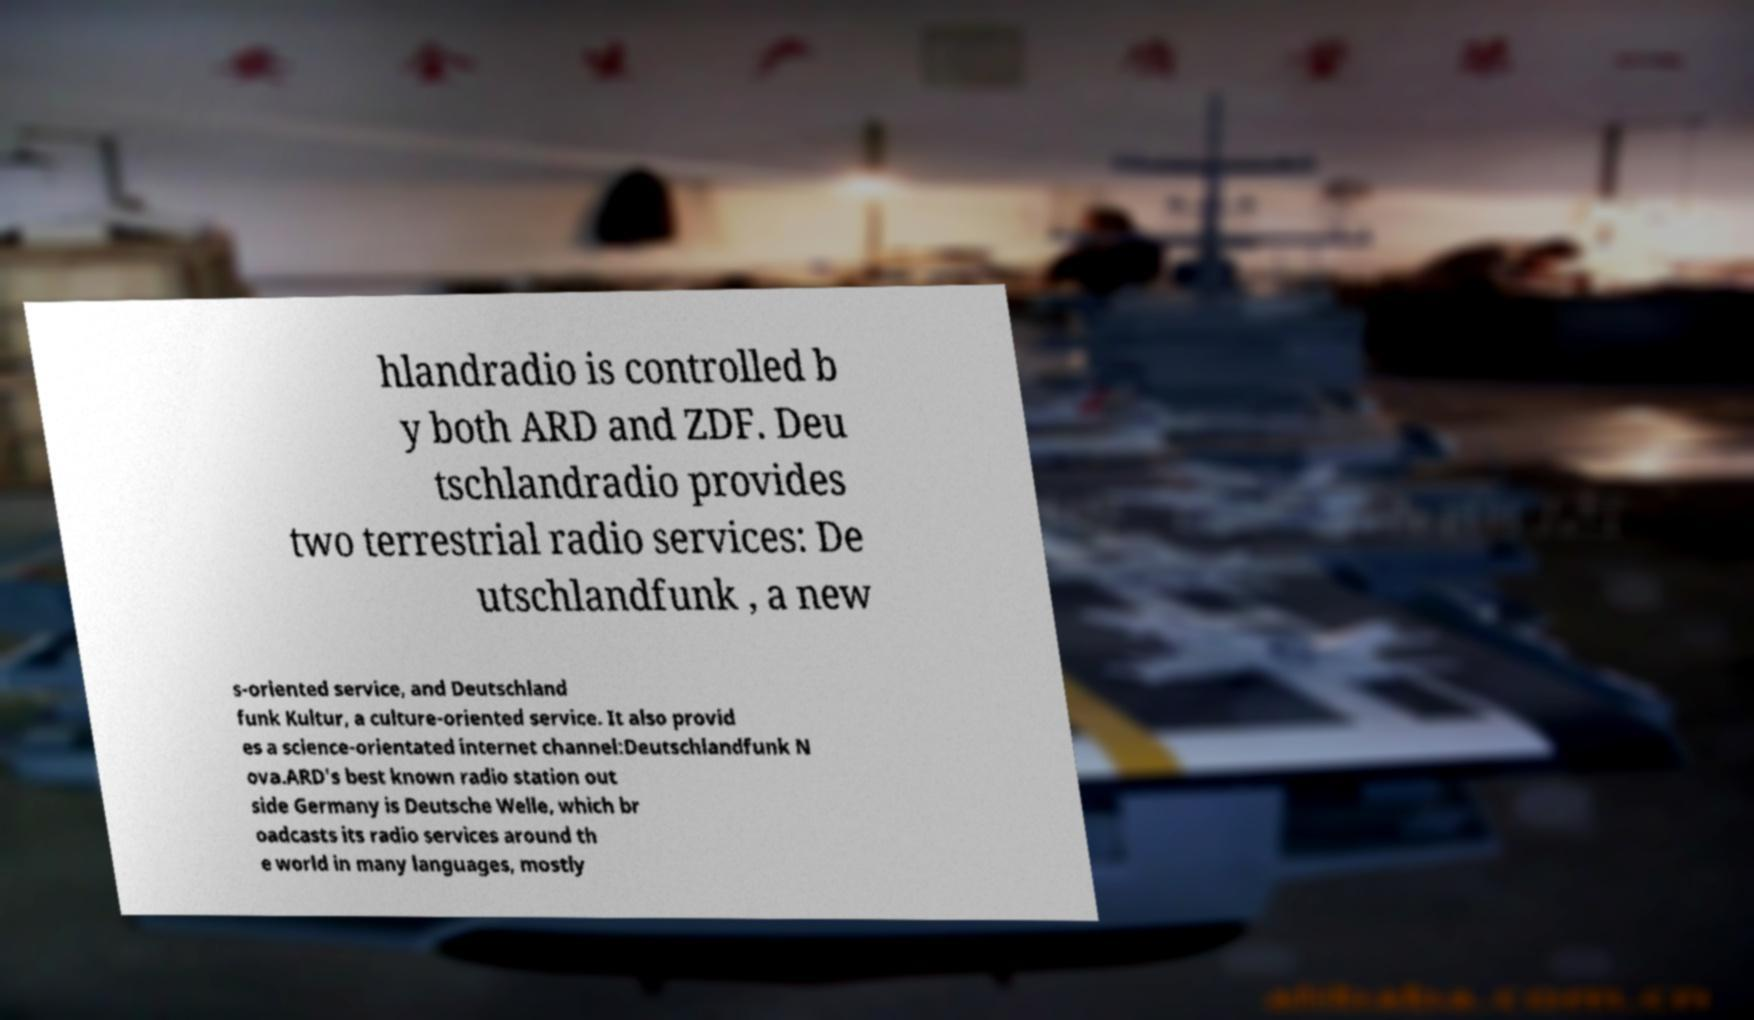Please identify and transcribe the text found in this image. hlandradio is controlled b y both ARD and ZDF. Deu tschlandradio provides two terrestrial radio services: De utschlandfunk , a new s-oriented service, and Deutschland funk Kultur, a culture-oriented service. It also provid es a science-orientated internet channel:Deutschlandfunk N ova.ARD's best known radio station out side Germany is Deutsche Welle, which br oadcasts its radio services around th e world in many languages, mostly 